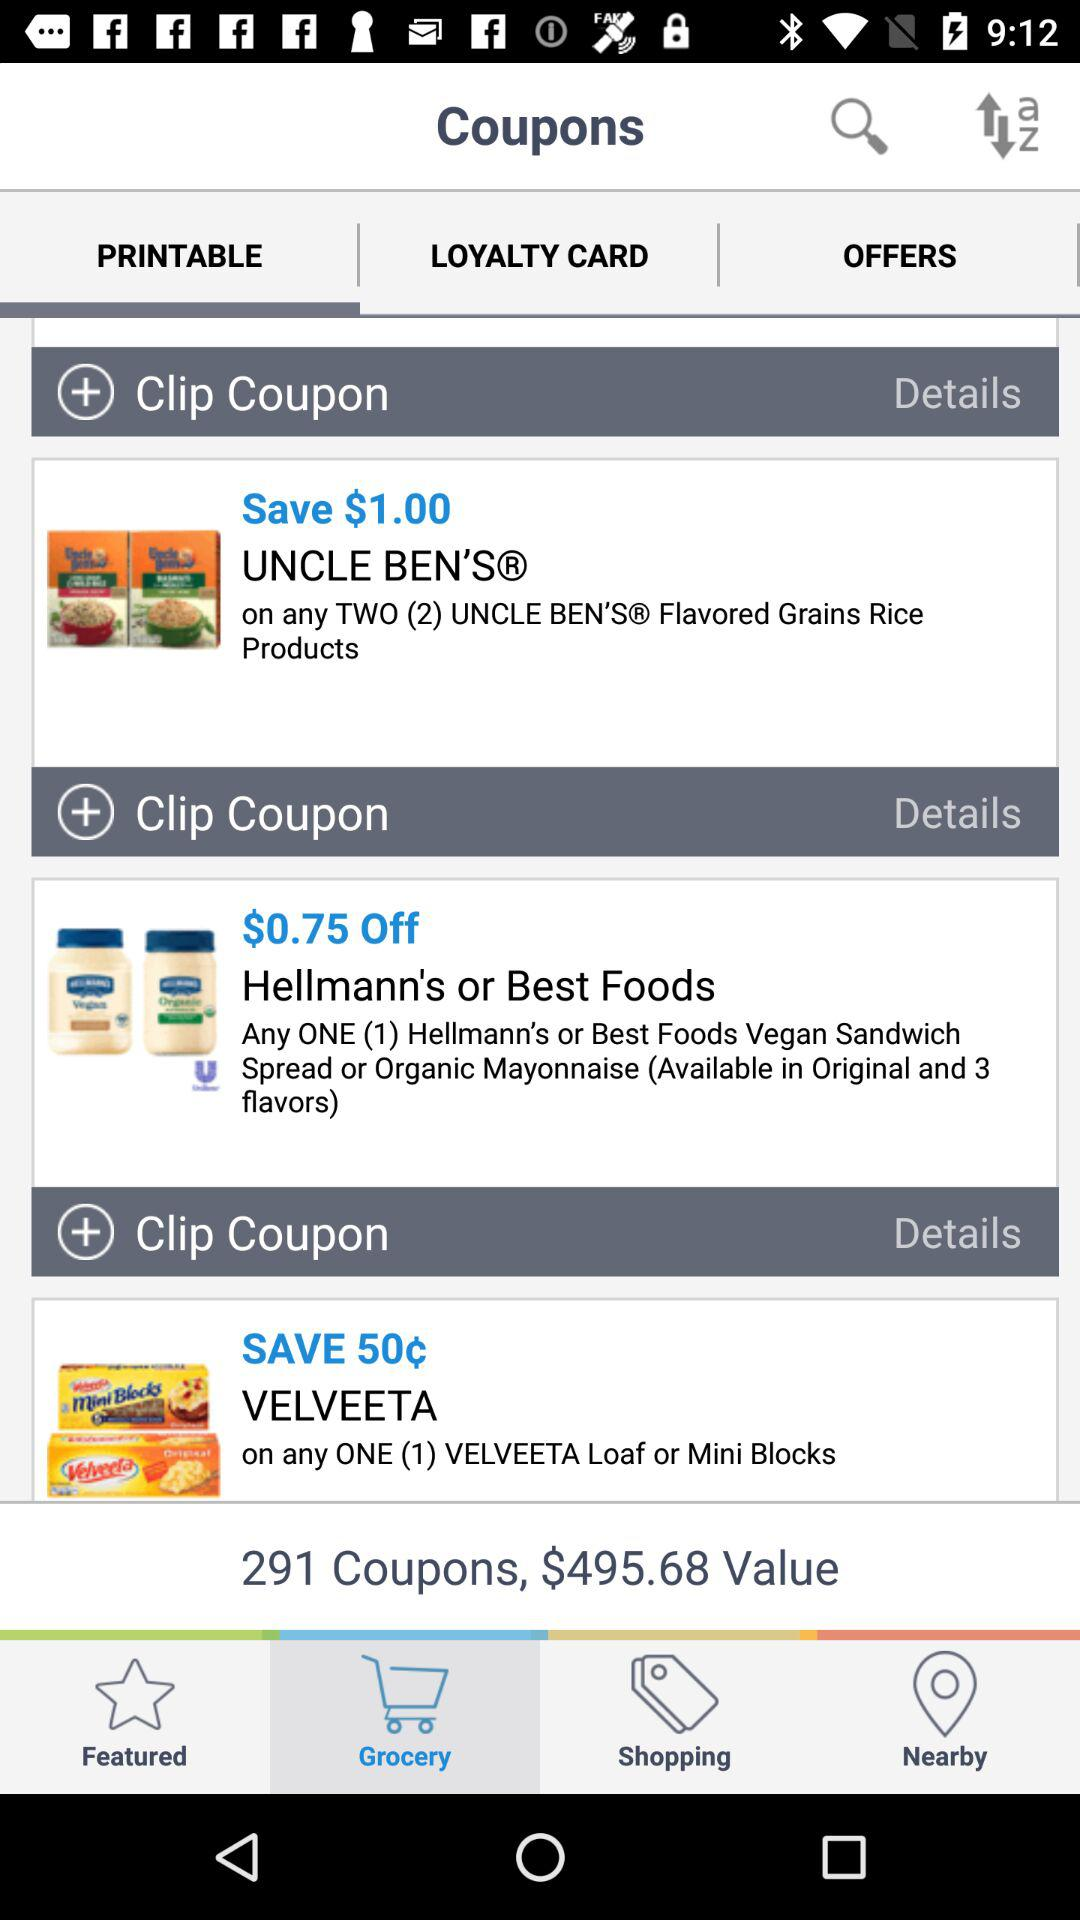How much money can be saved on the "VELVEETA" product? On the "VELVEETA" product, 50¢ can be saved. 